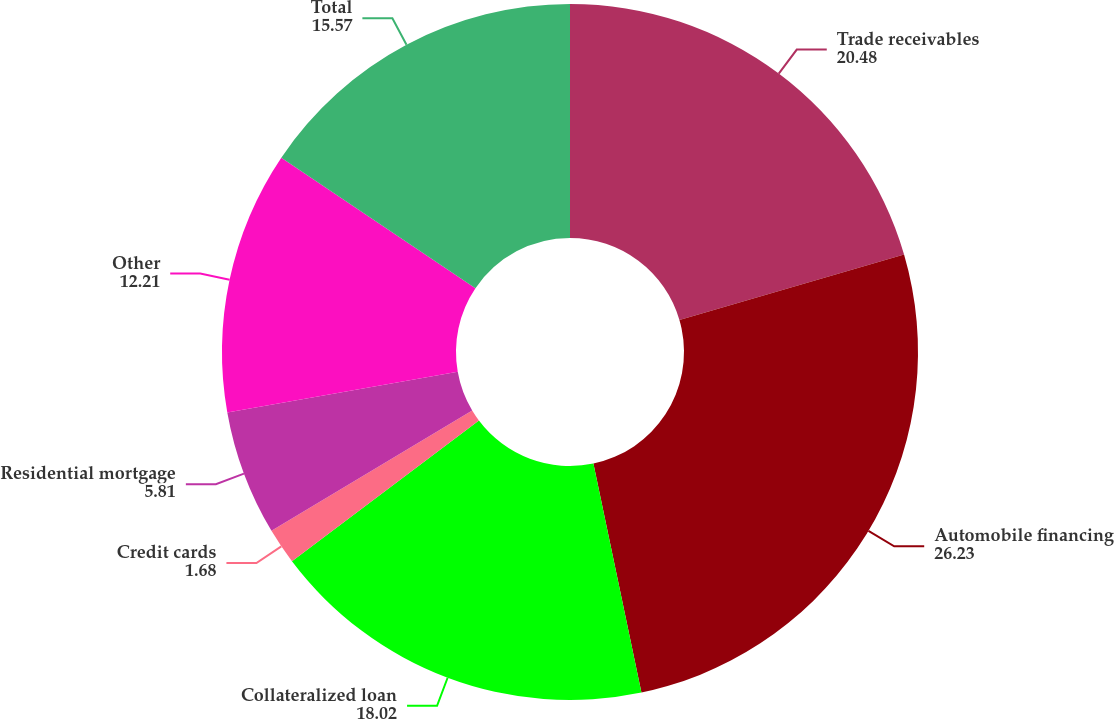Convert chart. <chart><loc_0><loc_0><loc_500><loc_500><pie_chart><fcel>Trade receivables<fcel>Automobile financing<fcel>Collateralized loan<fcel>Credit cards<fcel>Residential mortgage<fcel>Other<fcel>Total<nl><fcel>20.48%<fcel>26.23%<fcel>18.02%<fcel>1.68%<fcel>5.81%<fcel>12.21%<fcel>15.57%<nl></chart> 